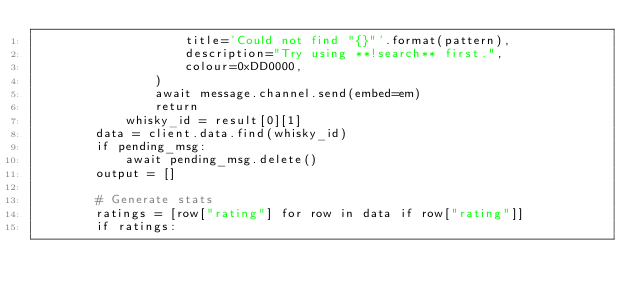<code> <loc_0><loc_0><loc_500><loc_500><_Python_>                    title='Could not find "{}"'.format(pattern),
                    description="Try using **!search** first.",
                    colour=0xDD0000,
                )
                await message.channel.send(embed=em)
                return
            whisky_id = result[0][1]
        data = client.data.find(whisky_id)
        if pending_msg:
            await pending_msg.delete()
        output = []

        # Generate stats
        ratings = [row["rating"] for row in data if row["rating"]]
        if ratings:</code> 